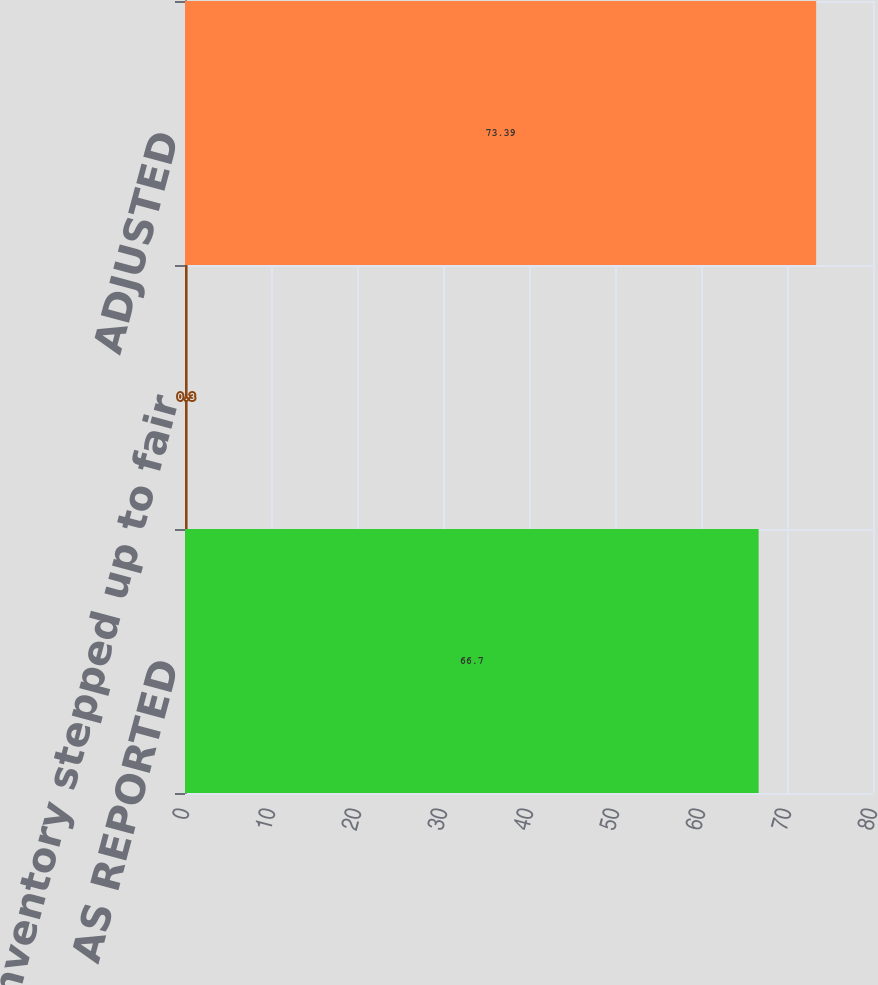Convert chart. <chart><loc_0><loc_0><loc_500><loc_500><bar_chart><fcel>AS REPORTED<fcel>Inventory stepped up to fair<fcel>ADJUSTED<nl><fcel>66.7<fcel>0.3<fcel>73.39<nl></chart> 